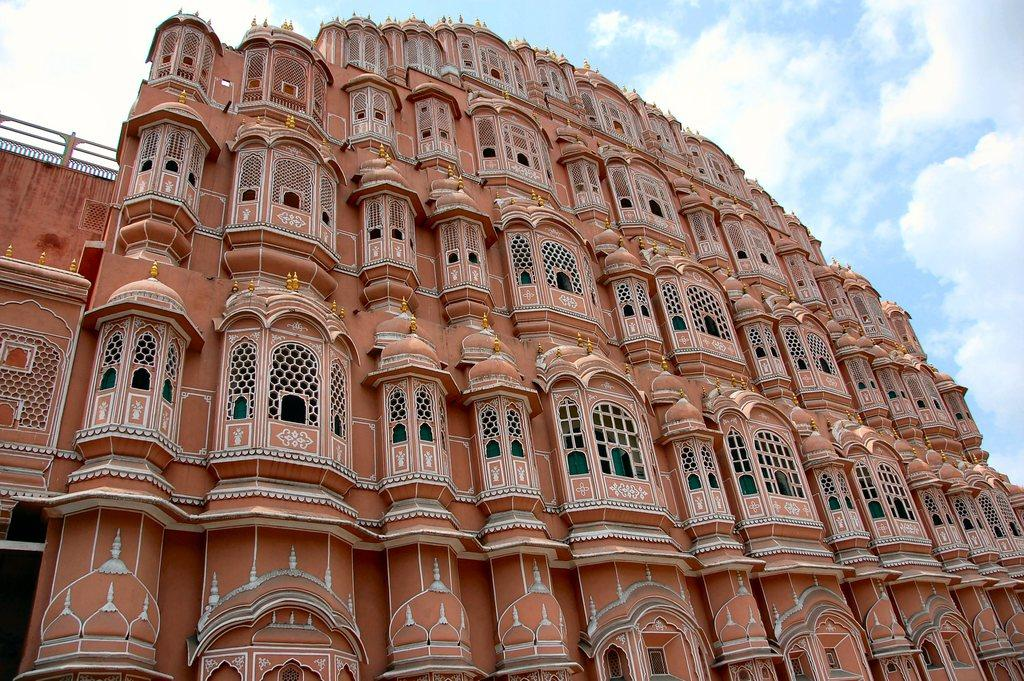What is the main structure visible in the front of the image? There is a building in the front of the image. What is the condition of the sky in the image? The sky is cloudy in the image. How many eyes can be seen on the building in the image? There are no eyes visible on the building in the image. 